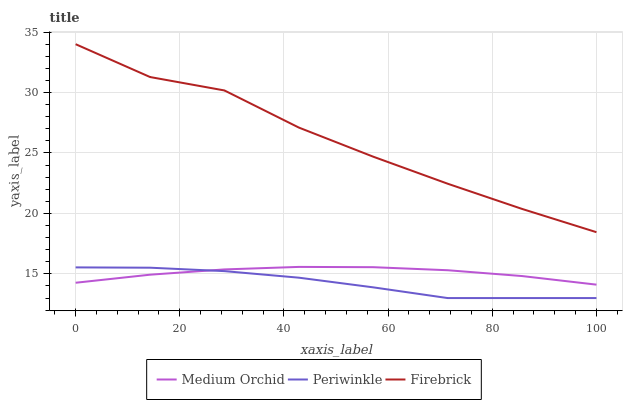Does Medium Orchid have the minimum area under the curve?
Answer yes or no. No. Does Medium Orchid have the maximum area under the curve?
Answer yes or no. No. Is Periwinkle the smoothest?
Answer yes or no. No. Is Periwinkle the roughest?
Answer yes or no. No. Does Medium Orchid have the lowest value?
Answer yes or no. No. Does Medium Orchid have the highest value?
Answer yes or no. No. Is Medium Orchid less than Firebrick?
Answer yes or no. Yes. Is Firebrick greater than Periwinkle?
Answer yes or no. Yes. Does Medium Orchid intersect Firebrick?
Answer yes or no. No. 